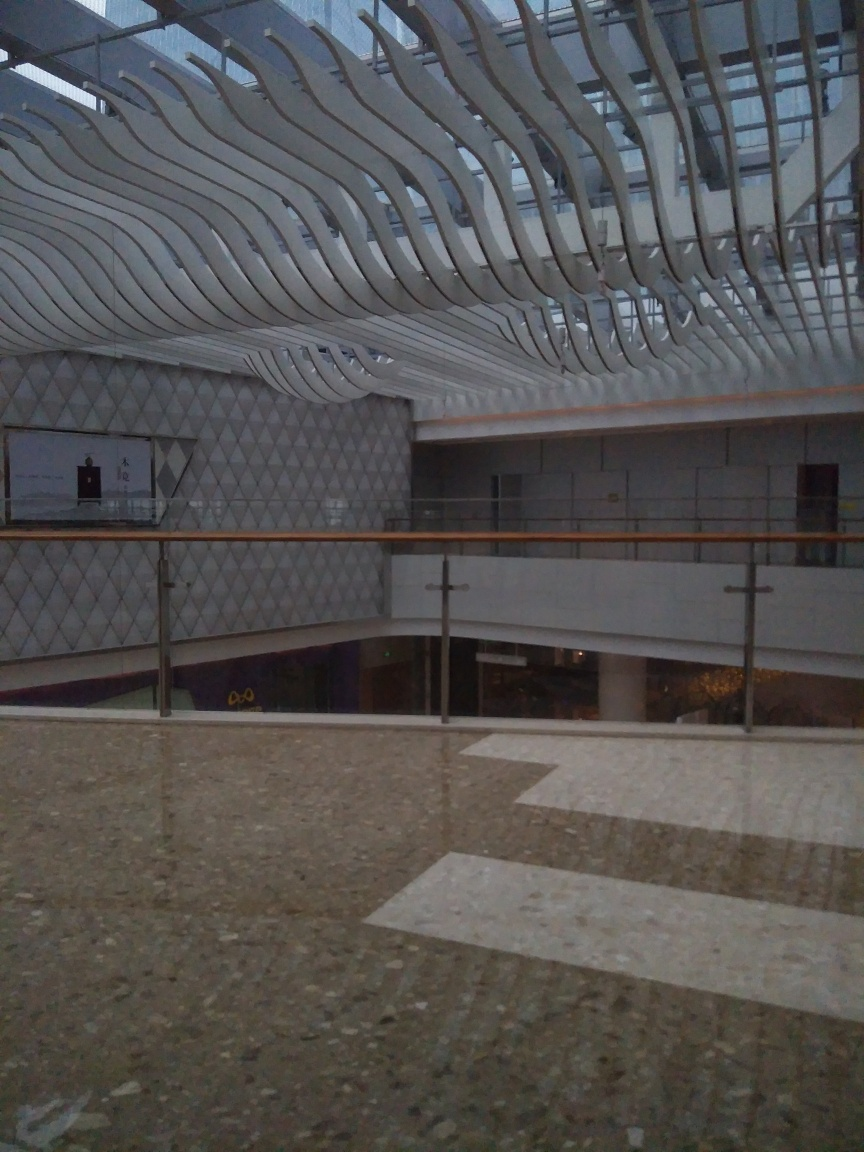Are there any quality issues with this image? Yes, the image does appear to suffer from some quality issues. The most notable problem is the lighting; it seems quite dim, perhaps due to low ambient light or a low camera exposure setting, which affects the visibility of the details. There appears to be a moderate amount of grain or noise, which suggests a high ISO setting was used, often a result of trying to compensate for poor lighting. Moreover, the photo might be slightly blurry, which could be due to camera shake or focus issues. 